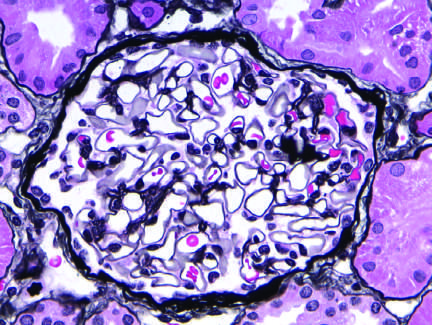what appears normal, with a delicate basement membrane?
Answer the question using a single word or phrase. The silver methenamine-stained glomerulus 